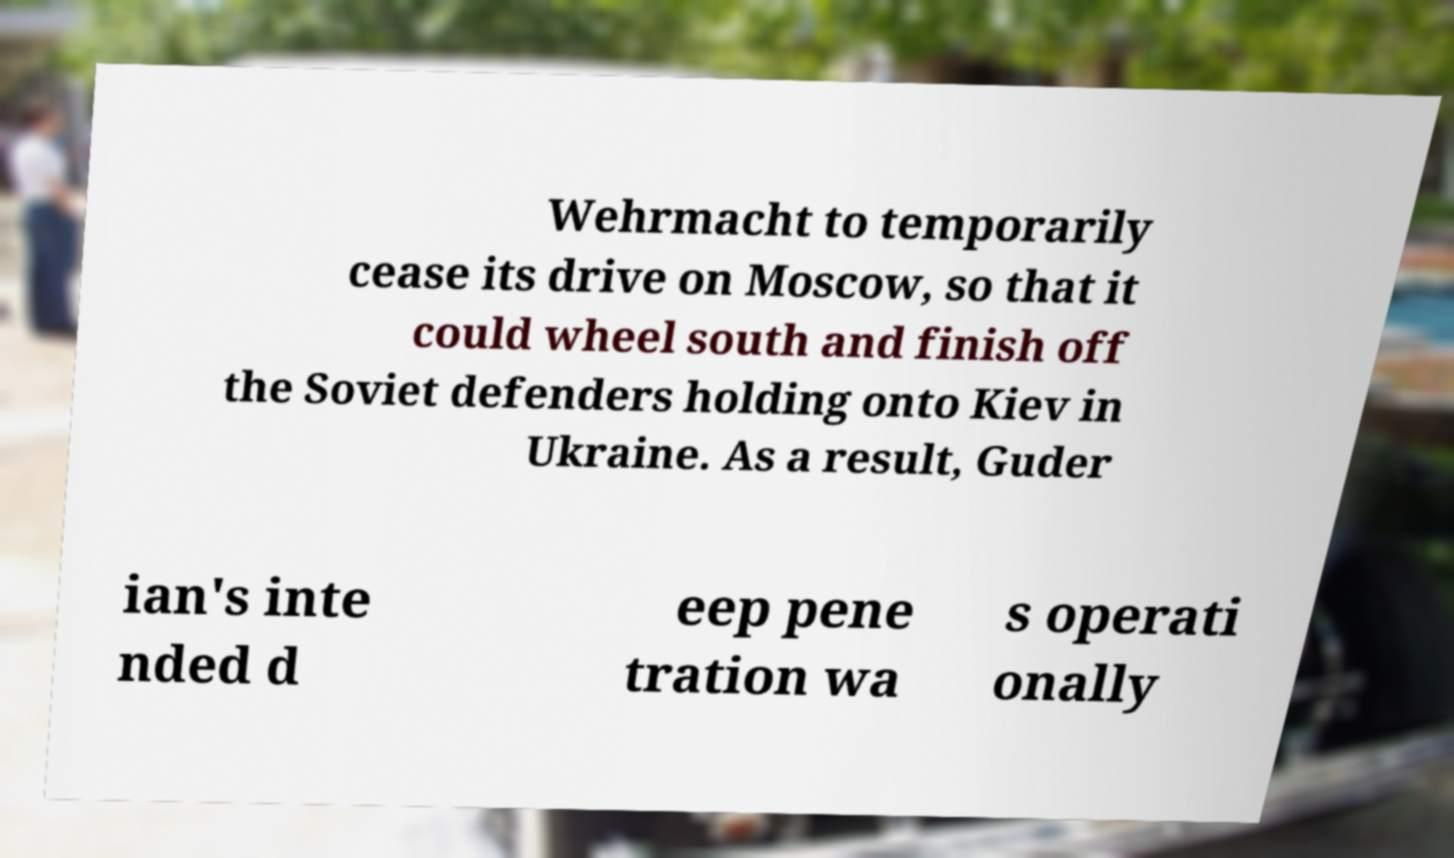Could you extract and type out the text from this image? Wehrmacht to temporarily cease its drive on Moscow, so that it could wheel south and finish off the Soviet defenders holding onto Kiev in Ukraine. As a result, Guder ian's inte nded d eep pene tration wa s operati onally 